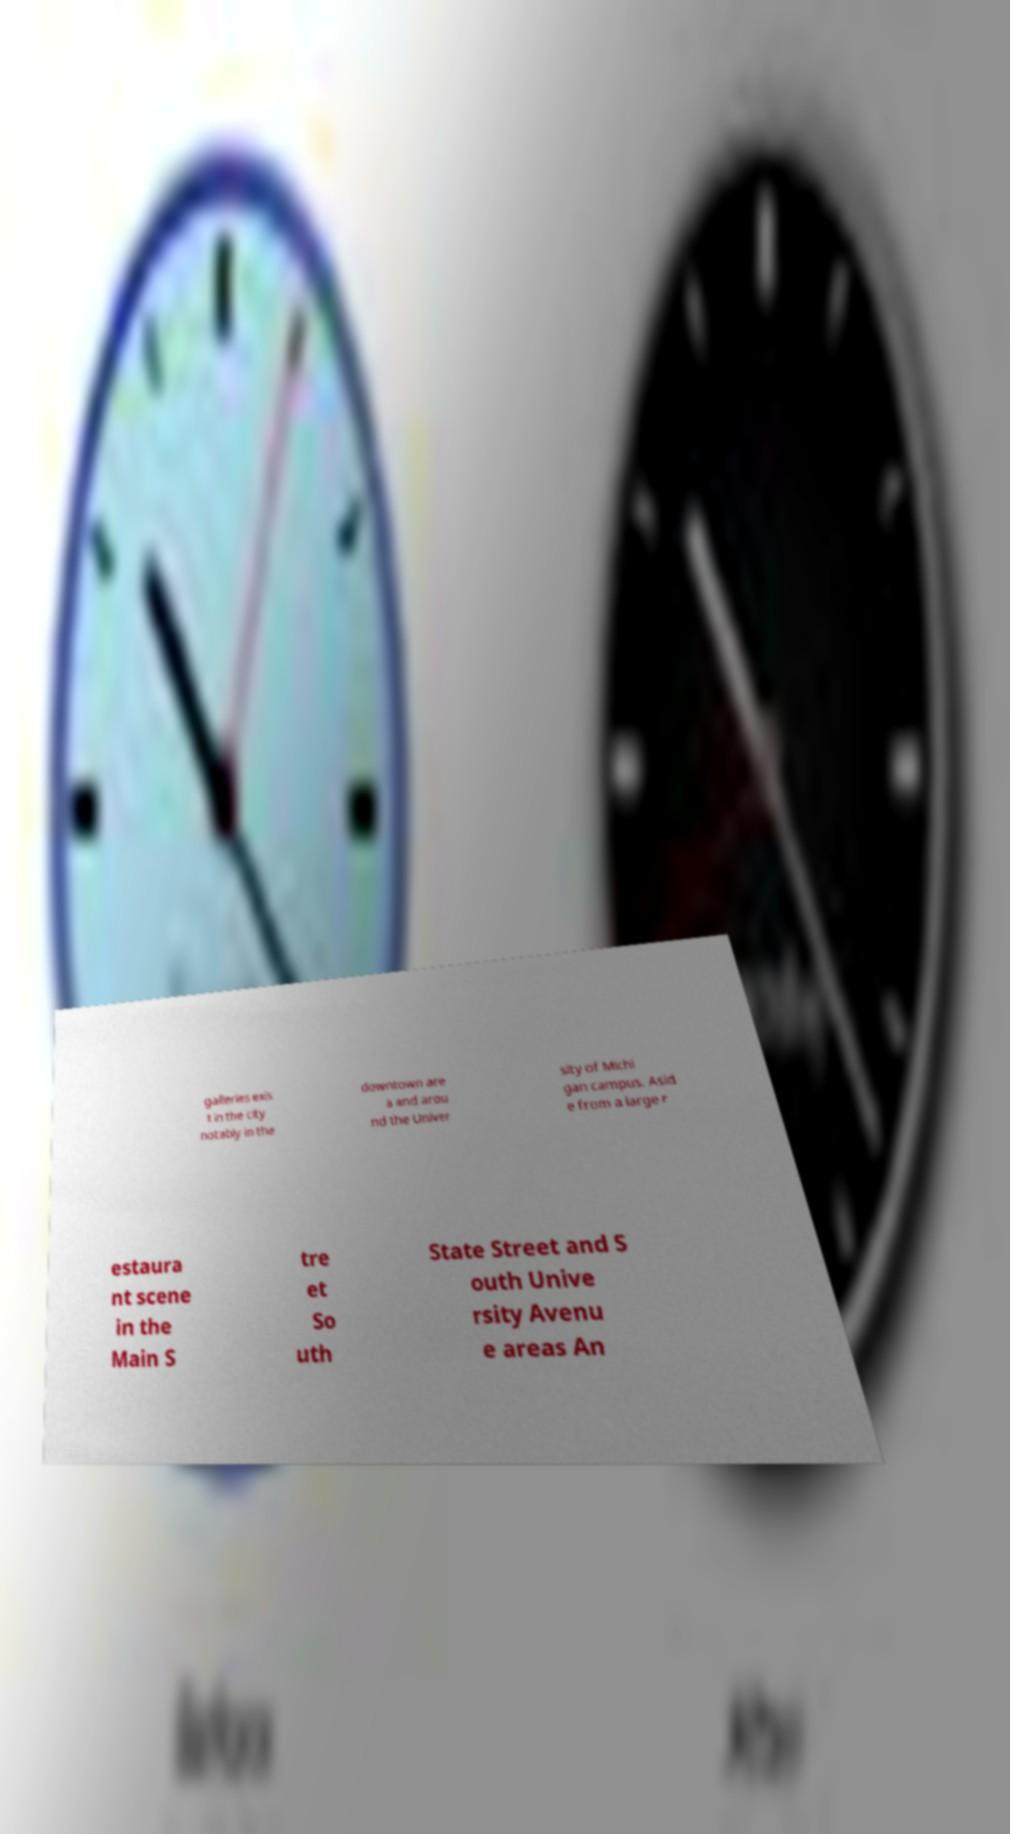There's text embedded in this image that I need extracted. Can you transcribe it verbatim? galleries exis t in the city notably in the downtown are a and arou nd the Univer sity of Michi gan campus. Asid e from a large r estaura nt scene in the Main S tre et So uth State Street and S outh Unive rsity Avenu e areas An 